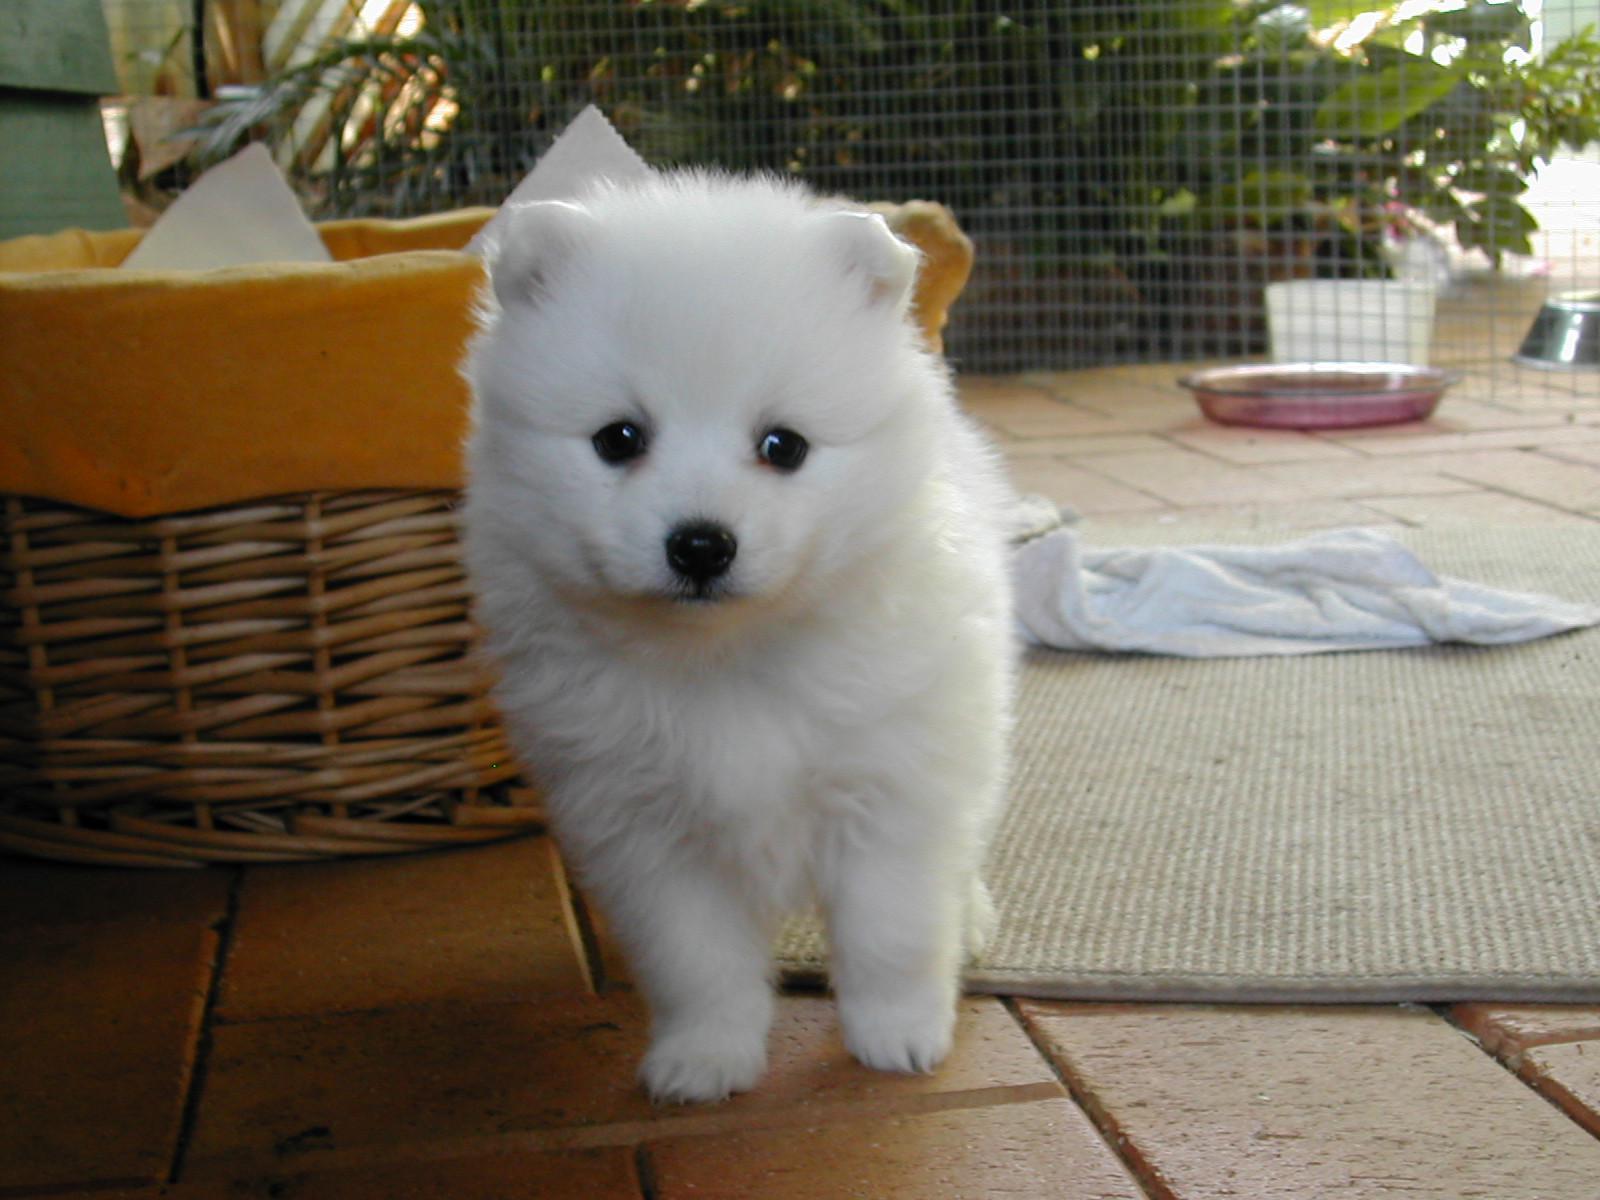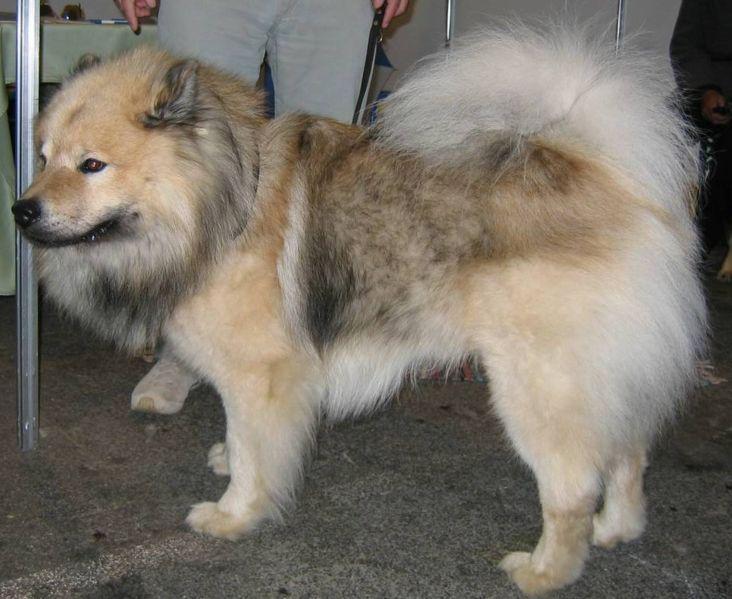The first image is the image on the left, the second image is the image on the right. Considering the images on both sides, is "A single dog is standing on all fours in the image on the right." valid? Answer yes or no. Yes. The first image is the image on the left, the second image is the image on the right. Evaluate the accuracy of this statement regarding the images: "The combined images include two fluffy puppies with similar poses, expressions and colors.". Is it true? Answer yes or no. No. 